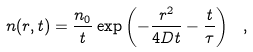<formula> <loc_0><loc_0><loc_500><loc_500>n ( r , t ) = \frac { n _ { 0 } } { t } \exp \left ( - \frac { r ^ { 2 } } { 4 D t } - \frac { t } { \tau } \right ) \ ,</formula> 